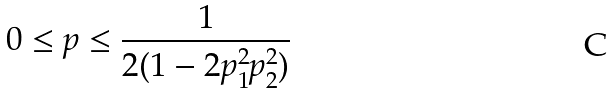Convert formula to latex. <formula><loc_0><loc_0><loc_500><loc_500>0 \leq p \leq \frac { 1 } { 2 ( 1 - 2 p _ { 1 } ^ { 2 } p _ { 2 } ^ { 2 } ) }</formula> 